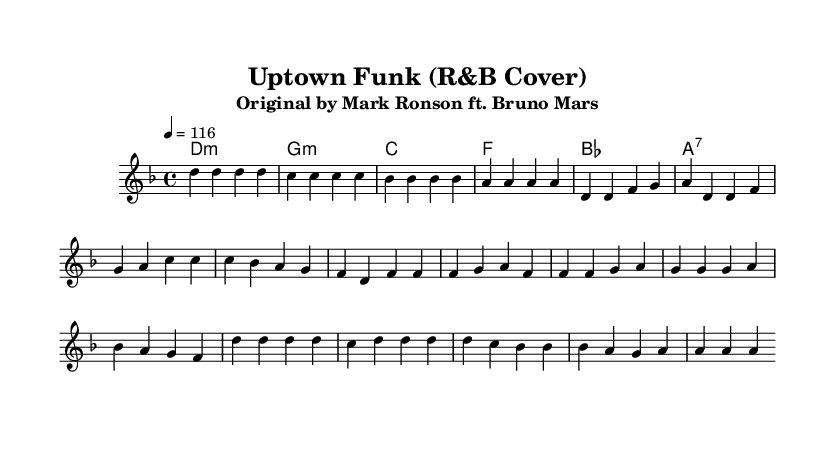What is the key signature of this music? The key signature for this piece is D minor. This can be determined by looking at the key signature indicated at the beginning of the score, which has one flat.
Answer: D minor What is the time signature of this music? The time signature is 4/4, which is shown at the beginning of the score. This means there are four beats in each measure and the quarter note gets one beat.
Answer: 4/4 What is the tempo marking for this piece? The tempo marking is 116 BPM (beats per minute), noted at the start with "4 = 116". This indicates the speed of the piece.
Answer: 116 How many measures are in the chorus section? The chorus section consists of four measures, as indicated by the grouping of the melody notes and the measure separators in the score.
Answer: 4 What chord follows the D minor chord in the harmony? The chord that follows the D minor is G minor. This is found by looking at the chord progression, where the D minor chord is followed by G minor in the chord line.
Answer: G minor What type of cover is this arrangement of "Uptown Funk"? This arrangement is an R&B cover, as noted in the title and subtitle. R&B stands for Rhythm and Blues, which shapes the style and feel of the music.
Answer: R&B How many different notes are in the melody of the verse? There are six distinct notes used in the melody of the verse: D, F, G, A, C, and B flat. Analyzing the melody line shows these unique pitches.
Answer: 6 